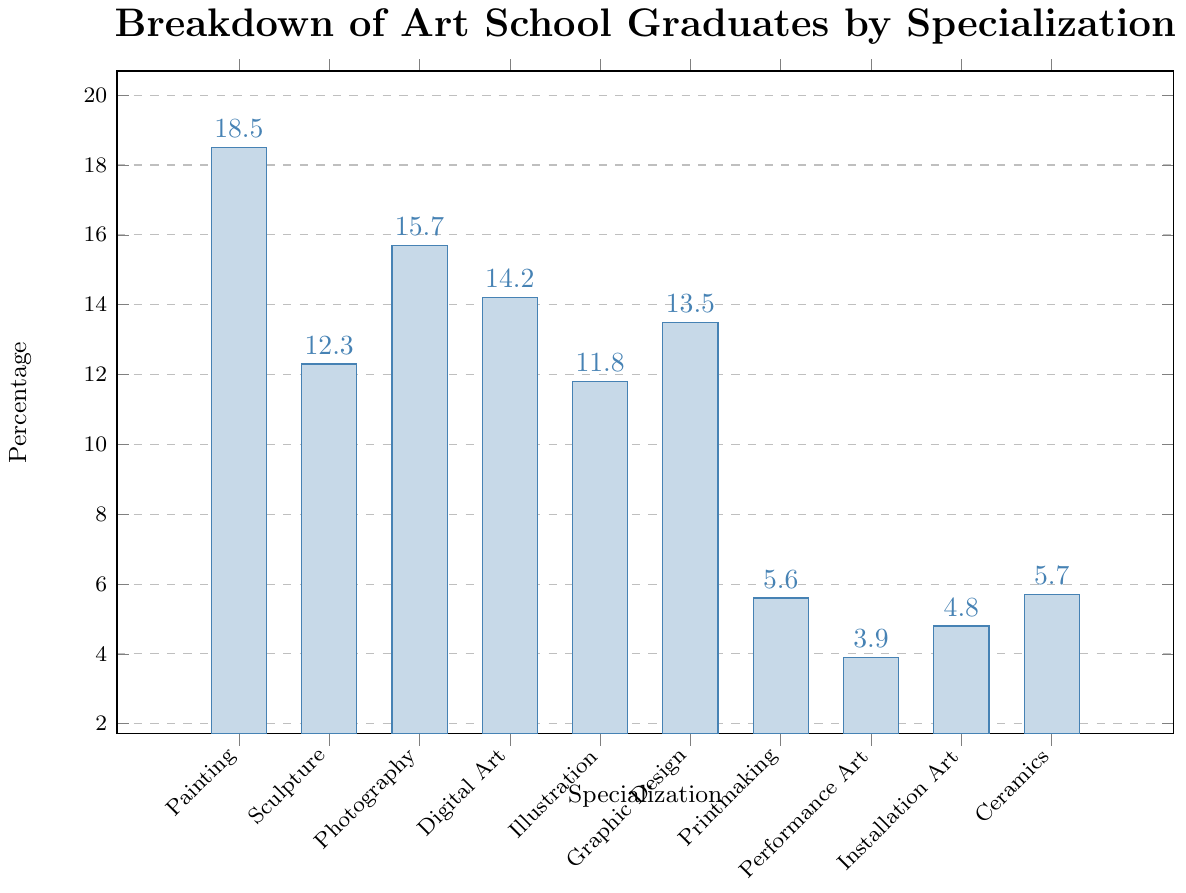what is the specialization with the highest percentage? Looking at the bar chart, the tallest bar represents the specialization with the highest percentage, which is Painting.
Answer: Painting Which specialization has a higher percentage, Photography or Digital Art? Based on the bar chart, the bar for Photography is taller than the bar for Digital Art, indicating that Photography has a higher percentage.
Answer: Photography What is the combined percentage of Illustration, Graphic Design, and Digital Art? Add the percentages for Illustration (11.8), Graphic Design (13.5), and Digital Art (14.2): 11.8 + 13.5 + 14.2 = 39.5
Answer: 39.5 Is the percentage of Ceramics more than twice the percentage of Performance Art? Ceramics has a percentage of 5.7 and Performance Art has 3.9. Twice 3.9 is 7.8, which is greater than 5.7, so Ceramics is not more than twice Performance Art.
Answer: No Which specialization has the smallest percentage, and what is it? The shortest bar on the chart represents Performance Art, which has the smallest percentage of 3.9.
Answer: Performance Art, 3.9 How much higher is the percentage of Painting compared to Sculpture? Subtract the percentage of Sculpture (12.3) from the percentage of Painting (18.5): 18.5 - 12.3 = 6.2
Answer: 6.2 What percent of graduates specialized in Printmaking or Performance Art combined? Add the percentages of Printmaking (5.6) and Performance Art (3.9): 5.6 + 3.9 = 9.5
Answer: 9.5 Is the specialization with the third highest percentage more or less than 15%? The third highest percentage is Photography, which is 15.7, and that is more than 15%.
Answer: More How many specializations have a percentage below 10%? The bars for Printmaking (5.6), Performance Art (3.9), Installation Art (4.8), and Ceramics (5.7) are all below 10%, totaling four specializations.
Answer: Four Which two specializations have the closest percentages to each other? Illustration (11.8) and Graphic Design (13.5) have the closest percentages, with a difference of 13.5 - 11.8 = 1.7.
Answer: Illustration and Graphic Design 